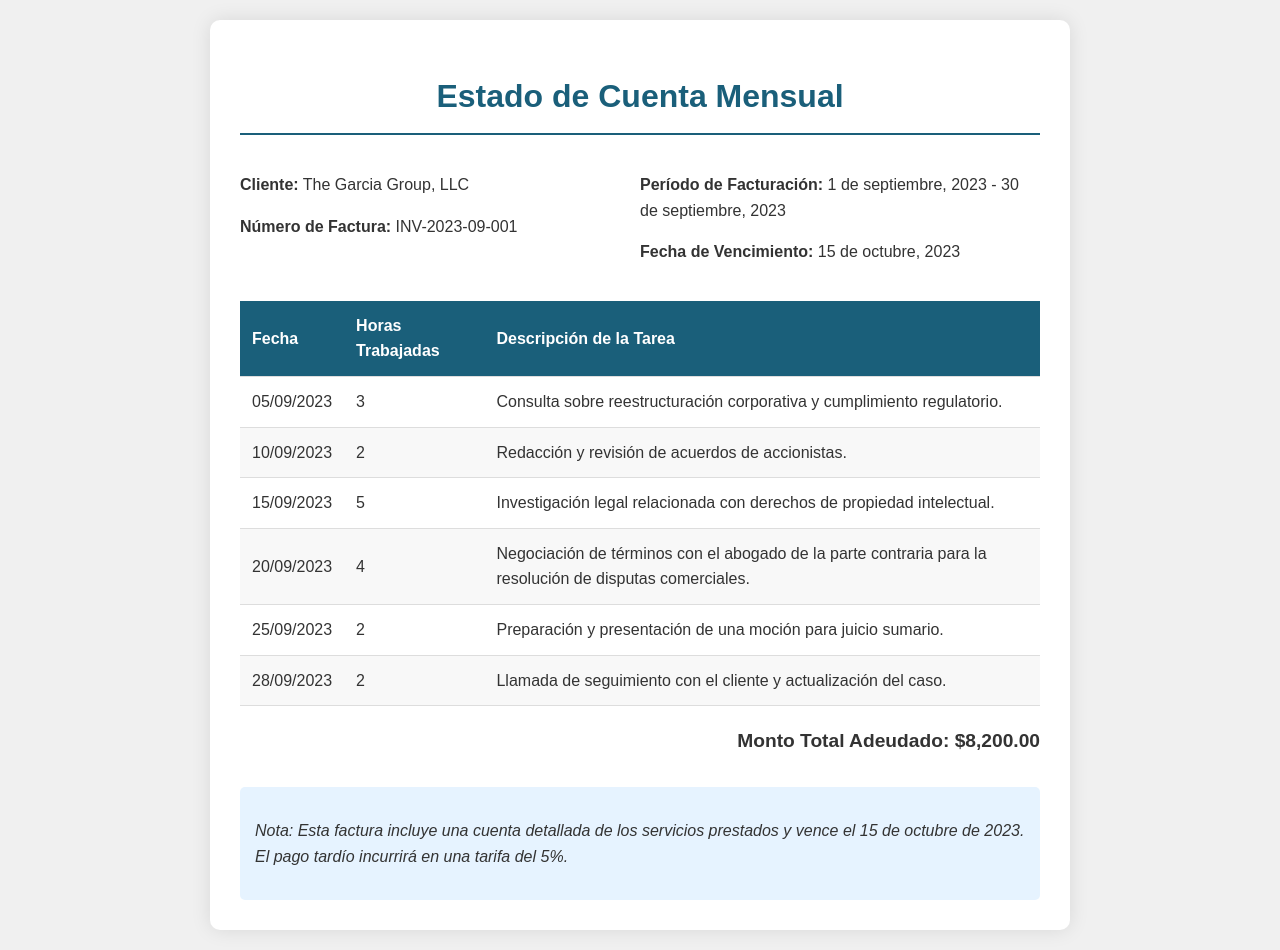¿Cuál es el nombre del cliente? El nombre del cliente se menciona en la parte superior del documento.
Answer: The Garcia Group, LLC ¿Qué número de factura se indica? El número de factura se encuentra cerca de la sección de cliente en el encabezado.
Answer: INV-2023-09-001 ¿Cuál es el período de facturación? El período de facturación se especifica en la parte derecha de la cabecera.
Answer: 1 de septiembre, 2023 - 30 de septiembre, 2023 ¿Cuál es el monto total adeudado? El monto total adeudado se encuentra en la sección de total al final del documento.
Answer: $8,200.00 ¿Cuántas horas se trabajaron el 15 de septiembre de 2023? Las horas trabajadas en esa fecha están listadas en la tabla de tareas.
Answer: 5 ¿Qué tarea se realizó el 10 de septiembre de 2023? La descripción de la tarea está indicada en la tabla junto a la fecha correspondiente.
Answer: Redacción y revisión de acuerdos de accionistas ¿Cuál es la fecha de vencimiento de la factura? La fecha de vencimiento se encuentra en la parte derecha de la cabecera.
Answer: 15 de octubre, 2023 ¿Qué sucederá si hay un pago tardío? La nota al final del documento menciona las consecuencias de un pago tardío.
Answer: Tarifa del 5% ¿Cuántas horas trabajó en total durante este mes? Para responder esta pregunta se deben sumar las horas trabajadas listadas en la tabla.
Answer: 18 ¿Qué tipo de servicios se detallan en este estado de cuenta? Se mencionan los servicios específicos realizados en la tabla con descripciones.
Answer: Servicios legales 